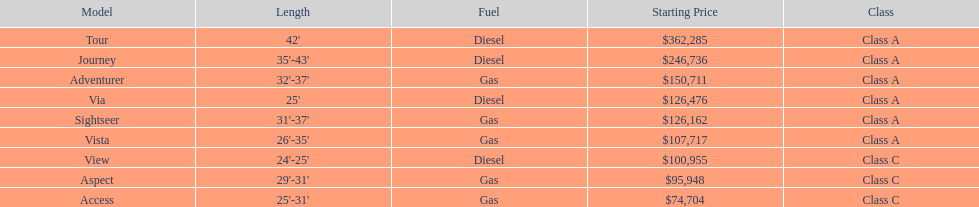Is the tour powered by diesel or gas? Diesel. 